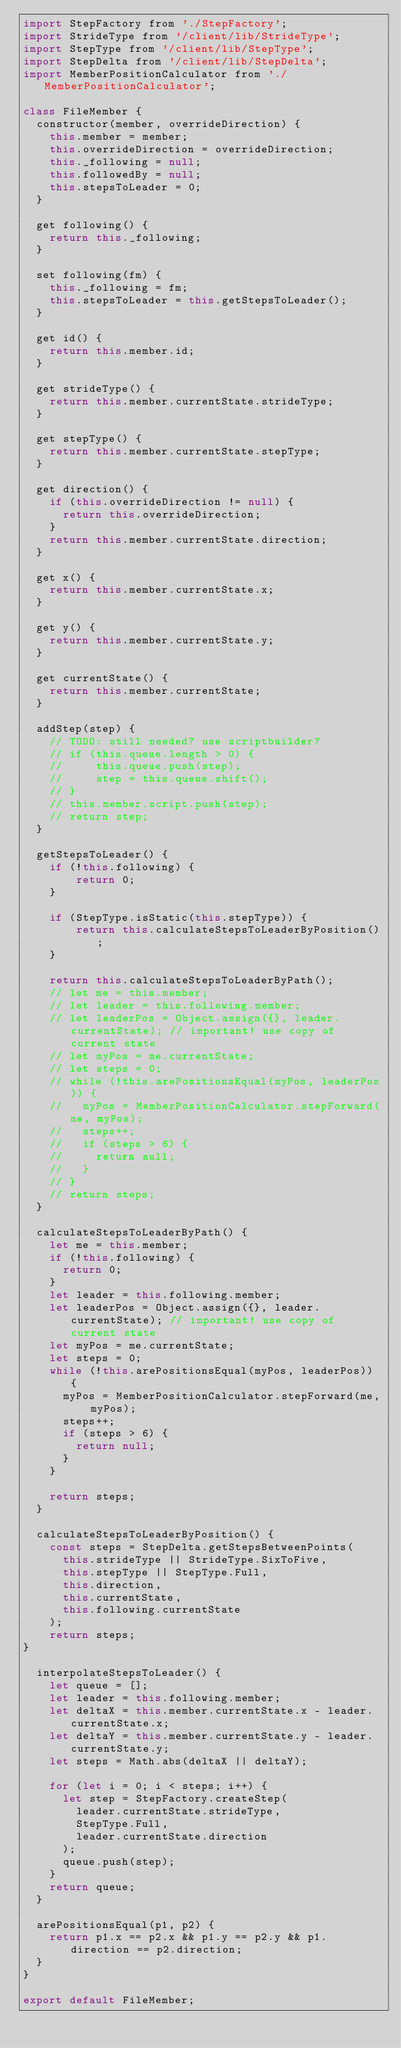Convert code to text. <code><loc_0><loc_0><loc_500><loc_500><_JavaScript_>import StepFactory from './StepFactory';
import StrideType from '/client/lib/StrideType';
import StepType from '/client/lib/StepType';
import StepDelta from '/client/lib/StepDelta';
import MemberPositionCalculator from './MemberPositionCalculator';

class FileMember {
  constructor(member, overrideDirection) {
    this.member = member;
    this.overrideDirection = overrideDirection;
    this._following = null;
    this.followedBy = null;
    this.stepsToLeader = 0;
  }

  get following() {
    return this._following;
  }

  set following(fm) {
    this._following = fm;
    this.stepsToLeader = this.getStepsToLeader();
  }

  get id() {
    return this.member.id;
  }

  get strideType() {
    return this.member.currentState.strideType;
  }

  get stepType() {
    return this.member.currentState.stepType;
  }

  get direction() {
    if (this.overrideDirection != null) {
      return this.overrideDirection;
    }
    return this.member.currentState.direction;
  }

  get x() {
    return this.member.currentState.x;
  }

  get y() {
    return this.member.currentState.y;
  }

  get currentState() {
    return this.member.currentState;
  }

  addStep(step) {
    // TODO: still needed? use scriptbuilder?
    // if (this.queue.length > 0) {
    //     this.queue.push(step);
    //     step = this.queue.shift();
    // }
    // this.member.script.push(step);
    // return step;
  }

  getStepsToLeader() {
    if (!this.following) {
        return 0;
    }

    if (StepType.isStatic(this.stepType)) {
        return this.calculateStepsToLeaderByPosition();
    }

    return this.calculateStepsToLeaderByPath();
    // let me = this.member;
    // let leader = this.following.member;
    // let leaderPos = Object.assign({}, leader.currentState); // important! use copy of current state
    // let myPos = me.currentState;
    // let steps = 0;
    // while (!this.arePositionsEqual(myPos, leaderPos)) {
    //   myPos = MemberPositionCalculator.stepForward(me, myPos);
    //   steps++;
    //   if (steps > 6) {
    //     return null;
    //   }
    // }
    // return steps;
  }

  calculateStepsToLeaderByPath() {
    let me = this.member;
    if (!this.following) {
      return 0;
    }
    let leader = this.following.member;
    let leaderPos = Object.assign({}, leader.currentState); // important! use copy of current state
    let myPos = me.currentState;
    let steps = 0;
    while (!this.arePositionsEqual(myPos, leaderPos)) {
      myPos = MemberPositionCalculator.stepForward(me, myPos);
      steps++;
      if (steps > 6) {
        return null;
      }
    }

    return steps;
  }

  calculateStepsToLeaderByPosition() {
    const steps = StepDelta.getStepsBetweenPoints(
      this.strideType || StrideType.SixToFive,
      this.stepType || StepType.Full,
      this.direction,
      this.currentState,
      this.following.currentState
    );
    return steps;
}

  interpolateStepsToLeader() {
    let queue = [];
    let leader = this.following.member;
    let deltaX = this.member.currentState.x - leader.currentState.x;
    let deltaY = this.member.currentState.y - leader.currentState.y;
    let steps = Math.abs(deltaX || deltaY);

    for (let i = 0; i < steps; i++) {
      let step = StepFactory.createStep(
        leader.currentState.strideType,
        StepType.Full,
        leader.currentState.direction
      );
      queue.push(step);
    }
    return queue;
  }

  arePositionsEqual(p1, p2) {
    return p1.x == p2.x && p1.y == p2.y && p1.direction == p2.direction;
  }
}

export default FileMember;
</code> 